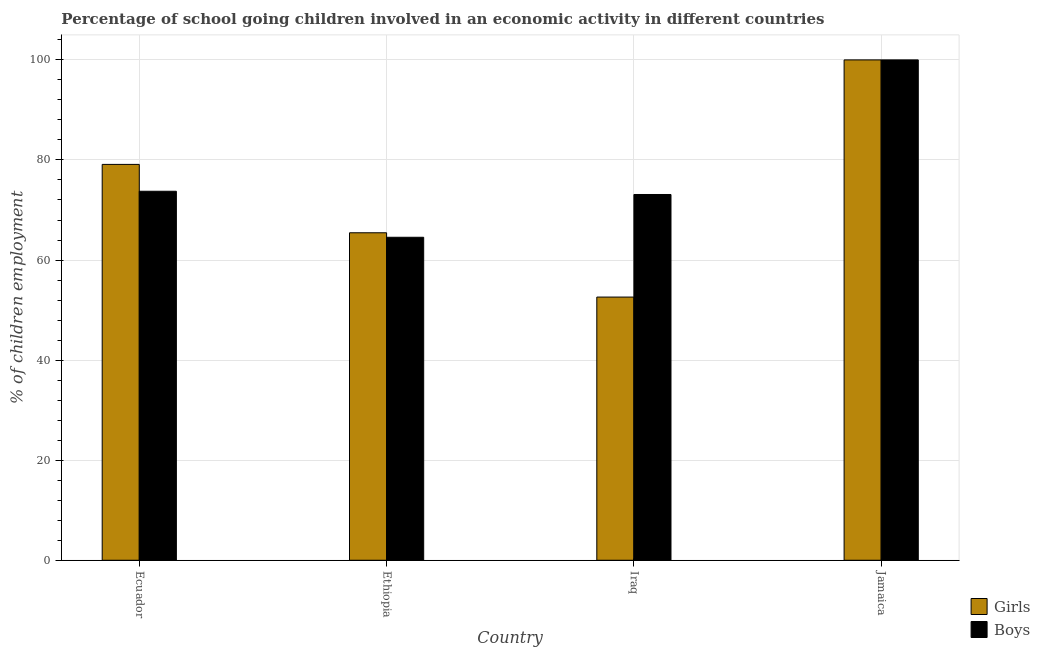How many different coloured bars are there?
Offer a very short reply. 2. Are the number of bars per tick equal to the number of legend labels?
Offer a terse response. Yes. Are the number of bars on each tick of the X-axis equal?
Ensure brevity in your answer.  Yes. How many bars are there on the 3rd tick from the left?
Your answer should be very brief. 2. What is the label of the 3rd group of bars from the left?
Offer a very short reply. Iraq. In how many cases, is the number of bars for a given country not equal to the number of legend labels?
Your response must be concise. 0. What is the percentage of school going boys in Jamaica?
Make the answer very short. 100. Across all countries, what is the maximum percentage of school going girls?
Provide a succinct answer. 100. Across all countries, what is the minimum percentage of school going girls?
Offer a very short reply. 52.6. In which country was the percentage of school going girls maximum?
Keep it short and to the point. Jamaica. In which country was the percentage of school going girls minimum?
Your answer should be compact. Iraq. What is the total percentage of school going girls in the graph?
Ensure brevity in your answer.  297.16. What is the difference between the percentage of school going boys in Ecuador and that in Iraq?
Give a very brief answer. 0.65. What is the difference between the percentage of school going girls in Iraq and the percentage of school going boys in Jamaica?
Provide a succinct answer. -47.4. What is the average percentage of school going boys per country?
Your response must be concise. 77.85. What is the difference between the percentage of school going girls and percentage of school going boys in Jamaica?
Ensure brevity in your answer.  0. What is the ratio of the percentage of school going boys in Ecuador to that in Iraq?
Your answer should be compact. 1.01. Is the percentage of school going girls in Iraq less than that in Jamaica?
Ensure brevity in your answer.  Yes. Is the difference between the percentage of school going boys in Ecuador and Iraq greater than the difference between the percentage of school going girls in Ecuador and Iraq?
Ensure brevity in your answer.  No. What is the difference between the highest and the second highest percentage of school going girls?
Your response must be concise. 20.89. What is the difference between the highest and the lowest percentage of school going girls?
Ensure brevity in your answer.  47.4. Is the sum of the percentage of school going boys in Ecuador and Iraq greater than the maximum percentage of school going girls across all countries?
Give a very brief answer. Yes. What does the 2nd bar from the left in Iraq represents?
Give a very brief answer. Boys. What does the 2nd bar from the right in Ethiopia represents?
Your response must be concise. Girls. Are all the bars in the graph horizontal?
Your answer should be very brief. No. Where does the legend appear in the graph?
Your answer should be compact. Bottom right. What is the title of the graph?
Provide a succinct answer. Percentage of school going children involved in an economic activity in different countries. Does "Net savings(excluding particulate emission damage)" appear as one of the legend labels in the graph?
Your answer should be very brief. No. What is the label or title of the Y-axis?
Provide a short and direct response. % of children employment. What is the % of children employment in Girls in Ecuador?
Your answer should be very brief. 79.11. What is the % of children employment of Boys in Ecuador?
Your response must be concise. 73.75. What is the % of children employment in Girls in Ethiopia?
Provide a short and direct response. 65.45. What is the % of children employment in Boys in Ethiopia?
Make the answer very short. 64.55. What is the % of children employment of Girls in Iraq?
Give a very brief answer. 52.6. What is the % of children employment in Boys in Iraq?
Offer a terse response. 73.1. Across all countries, what is the maximum % of children employment in Girls?
Give a very brief answer. 100. Across all countries, what is the minimum % of children employment of Girls?
Give a very brief answer. 52.6. Across all countries, what is the minimum % of children employment of Boys?
Provide a succinct answer. 64.55. What is the total % of children employment in Girls in the graph?
Your answer should be compact. 297.16. What is the total % of children employment in Boys in the graph?
Make the answer very short. 311.4. What is the difference between the % of children employment in Girls in Ecuador and that in Ethiopia?
Give a very brief answer. 13.66. What is the difference between the % of children employment in Boys in Ecuador and that in Ethiopia?
Make the answer very short. 9.2. What is the difference between the % of children employment of Girls in Ecuador and that in Iraq?
Provide a short and direct response. 26.51. What is the difference between the % of children employment of Boys in Ecuador and that in Iraq?
Give a very brief answer. 0.65. What is the difference between the % of children employment in Girls in Ecuador and that in Jamaica?
Offer a very short reply. -20.89. What is the difference between the % of children employment of Boys in Ecuador and that in Jamaica?
Offer a terse response. -26.25. What is the difference between the % of children employment of Girls in Ethiopia and that in Iraq?
Give a very brief answer. 12.85. What is the difference between the % of children employment in Boys in Ethiopia and that in Iraq?
Provide a short and direct response. -8.55. What is the difference between the % of children employment in Girls in Ethiopia and that in Jamaica?
Your response must be concise. -34.55. What is the difference between the % of children employment in Boys in Ethiopia and that in Jamaica?
Give a very brief answer. -35.45. What is the difference between the % of children employment of Girls in Iraq and that in Jamaica?
Your answer should be compact. -47.4. What is the difference between the % of children employment in Boys in Iraq and that in Jamaica?
Your answer should be compact. -26.9. What is the difference between the % of children employment of Girls in Ecuador and the % of children employment of Boys in Ethiopia?
Provide a succinct answer. 14.56. What is the difference between the % of children employment in Girls in Ecuador and the % of children employment in Boys in Iraq?
Provide a short and direct response. 6.01. What is the difference between the % of children employment of Girls in Ecuador and the % of children employment of Boys in Jamaica?
Your answer should be compact. -20.89. What is the difference between the % of children employment in Girls in Ethiopia and the % of children employment in Boys in Iraq?
Keep it short and to the point. -7.65. What is the difference between the % of children employment of Girls in Ethiopia and the % of children employment of Boys in Jamaica?
Make the answer very short. -34.55. What is the difference between the % of children employment of Girls in Iraq and the % of children employment of Boys in Jamaica?
Your answer should be compact. -47.4. What is the average % of children employment in Girls per country?
Offer a very short reply. 74.29. What is the average % of children employment in Boys per country?
Your response must be concise. 77.85. What is the difference between the % of children employment of Girls and % of children employment of Boys in Ecuador?
Provide a succinct answer. 5.37. What is the difference between the % of children employment in Girls and % of children employment in Boys in Ethiopia?
Offer a terse response. 0.9. What is the difference between the % of children employment in Girls and % of children employment in Boys in Iraq?
Give a very brief answer. -20.5. What is the difference between the % of children employment in Girls and % of children employment in Boys in Jamaica?
Your response must be concise. 0. What is the ratio of the % of children employment in Girls in Ecuador to that in Ethiopia?
Your answer should be very brief. 1.21. What is the ratio of the % of children employment of Boys in Ecuador to that in Ethiopia?
Ensure brevity in your answer.  1.14. What is the ratio of the % of children employment in Girls in Ecuador to that in Iraq?
Ensure brevity in your answer.  1.5. What is the ratio of the % of children employment in Boys in Ecuador to that in Iraq?
Your answer should be compact. 1.01. What is the ratio of the % of children employment in Girls in Ecuador to that in Jamaica?
Your response must be concise. 0.79. What is the ratio of the % of children employment in Boys in Ecuador to that in Jamaica?
Keep it short and to the point. 0.74. What is the ratio of the % of children employment in Girls in Ethiopia to that in Iraq?
Provide a short and direct response. 1.24. What is the ratio of the % of children employment of Boys in Ethiopia to that in Iraq?
Provide a short and direct response. 0.88. What is the ratio of the % of children employment of Girls in Ethiopia to that in Jamaica?
Offer a terse response. 0.65. What is the ratio of the % of children employment in Boys in Ethiopia to that in Jamaica?
Provide a short and direct response. 0.65. What is the ratio of the % of children employment in Girls in Iraq to that in Jamaica?
Make the answer very short. 0.53. What is the ratio of the % of children employment of Boys in Iraq to that in Jamaica?
Offer a terse response. 0.73. What is the difference between the highest and the second highest % of children employment of Girls?
Offer a terse response. 20.89. What is the difference between the highest and the second highest % of children employment in Boys?
Your answer should be very brief. 26.25. What is the difference between the highest and the lowest % of children employment of Girls?
Give a very brief answer. 47.4. What is the difference between the highest and the lowest % of children employment of Boys?
Provide a succinct answer. 35.45. 